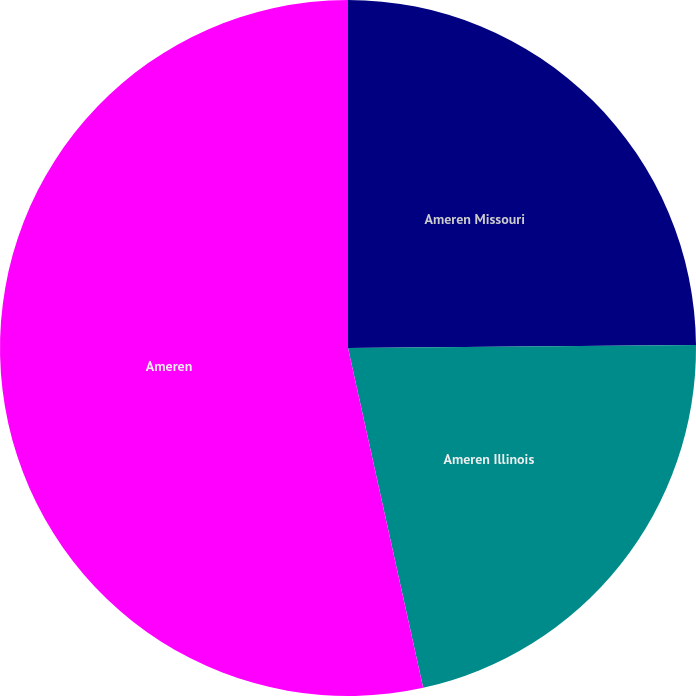Convert chart. <chart><loc_0><loc_0><loc_500><loc_500><pie_chart><fcel>Ameren Missouri<fcel>Ameren Illinois<fcel>Ameren<nl><fcel>24.86%<fcel>21.68%<fcel>53.47%<nl></chart> 